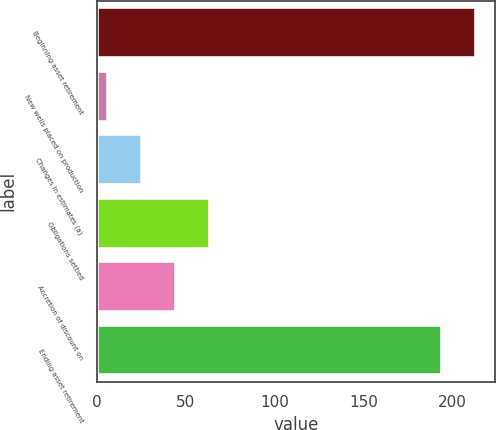Convert chart to OTSL. <chart><loc_0><loc_0><loc_500><loc_500><bar_chart><fcel>Beginning asset retirement<fcel>New wells placed on production<fcel>Changes in estimates (a)<fcel>Obligations settled<fcel>Accretion of discount on<fcel>Ending asset retirement<nl><fcel>213.2<fcel>6<fcel>25.2<fcel>63.6<fcel>44.4<fcel>194<nl></chart> 